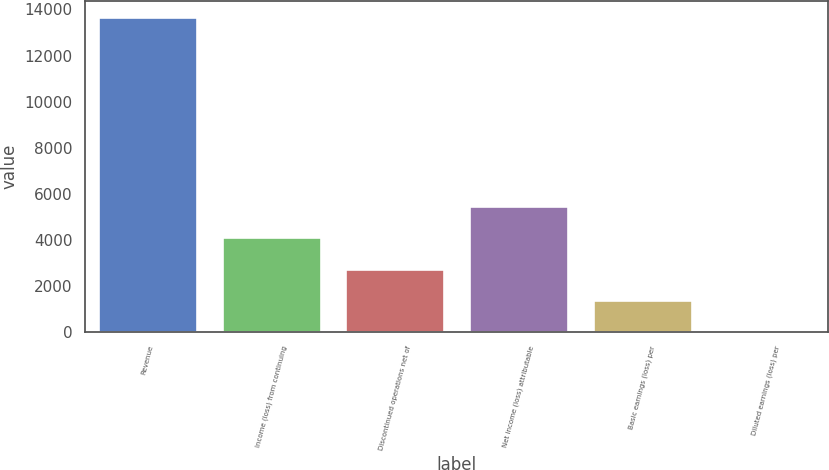Convert chart. <chart><loc_0><loc_0><loc_500><loc_500><bar_chart><fcel>Revenue<fcel>Income (loss) from continuing<fcel>Discontinued operations net of<fcel>Net income (loss) attributable<fcel>Basic earnings (loss) per<fcel>Diluted earnings (loss) per<nl><fcel>13668<fcel>4101.68<fcel>2735.06<fcel>5468.3<fcel>1368.44<fcel>1.82<nl></chart> 